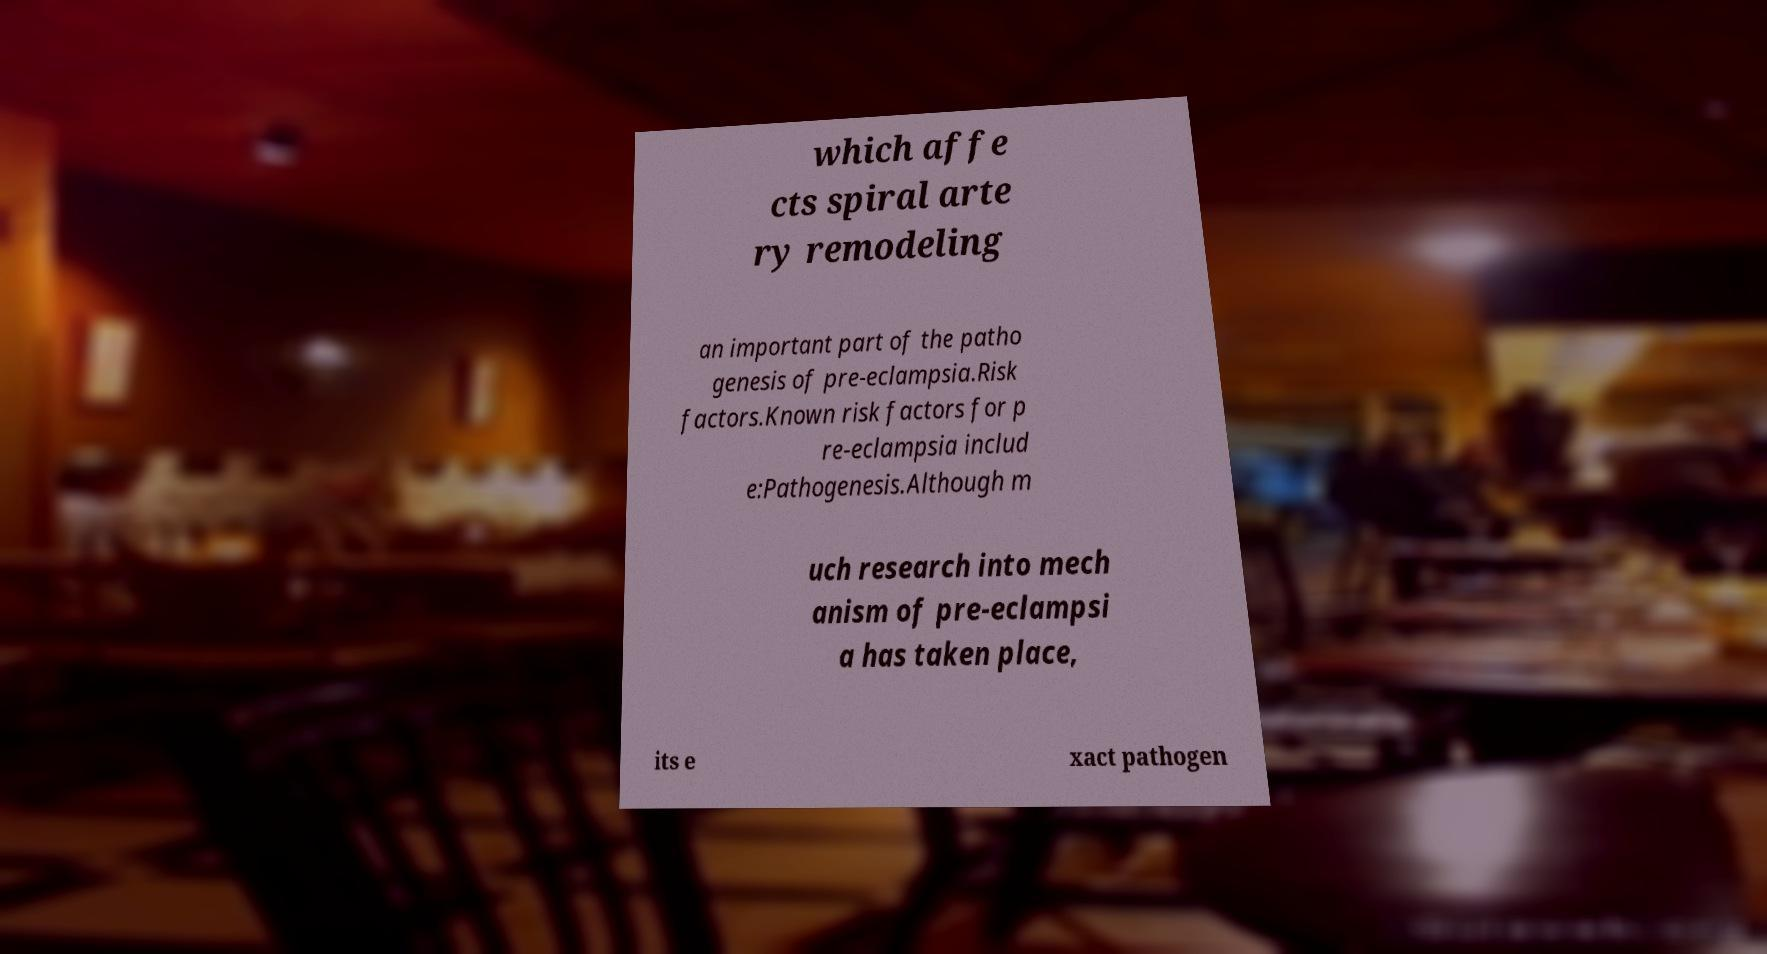Could you assist in decoding the text presented in this image and type it out clearly? which affe cts spiral arte ry remodeling an important part of the patho genesis of pre-eclampsia.Risk factors.Known risk factors for p re-eclampsia includ e:Pathogenesis.Although m uch research into mech anism of pre-eclampsi a has taken place, its e xact pathogen 